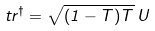<formula> <loc_0><loc_0><loc_500><loc_500>t r ^ { \dagger } = \sqrt { ( 1 - T ) T } \, U</formula> 